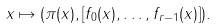Convert formula to latex. <formula><loc_0><loc_0><loc_500><loc_500>x \mapsto ( \pi ( x ) , [ f _ { 0 } ( x ) , \dots , f _ { r - 1 } ( x ) ] ) .</formula> 